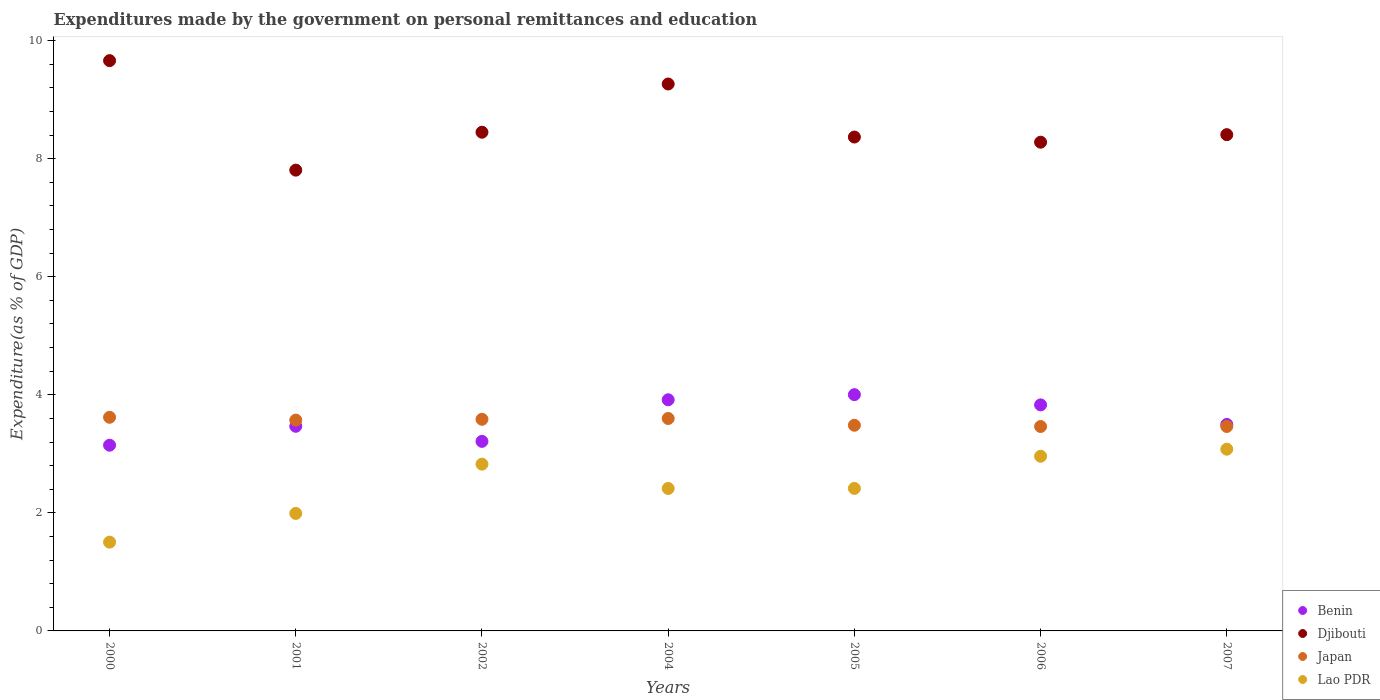Is the number of dotlines equal to the number of legend labels?
Ensure brevity in your answer.  Yes. What is the expenditures made by the government on personal remittances and education in Japan in 2001?
Keep it short and to the point. 3.57. Across all years, what is the maximum expenditures made by the government on personal remittances and education in Japan?
Provide a succinct answer. 3.62. Across all years, what is the minimum expenditures made by the government on personal remittances and education in Lao PDR?
Offer a terse response. 1.5. In which year was the expenditures made by the government on personal remittances and education in Lao PDR minimum?
Offer a terse response. 2000. What is the total expenditures made by the government on personal remittances and education in Djibouti in the graph?
Your answer should be compact. 60.23. What is the difference between the expenditures made by the government on personal remittances and education in Japan in 2001 and that in 2007?
Ensure brevity in your answer.  0.11. What is the difference between the expenditures made by the government on personal remittances and education in Benin in 2002 and the expenditures made by the government on personal remittances and education in Lao PDR in 2007?
Offer a very short reply. 0.13. What is the average expenditures made by the government on personal remittances and education in Benin per year?
Your answer should be compact. 3.58. In the year 2006, what is the difference between the expenditures made by the government on personal remittances and education in Djibouti and expenditures made by the government on personal remittances and education in Japan?
Your answer should be compact. 4.82. In how many years, is the expenditures made by the government on personal remittances and education in Lao PDR greater than 2 %?
Provide a short and direct response. 5. What is the ratio of the expenditures made by the government on personal remittances and education in Benin in 2002 to that in 2004?
Provide a succinct answer. 0.82. Is the difference between the expenditures made by the government on personal remittances and education in Djibouti in 2004 and 2005 greater than the difference between the expenditures made by the government on personal remittances and education in Japan in 2004 and 2005?
Your response must be concise. Yes. What is the difference between the highest and the second highest expenditures made by the government on personal remittances and education in Djibouti?
Your answer should be compact. 0.4. What is the difference between the highest and the lowest expenditures made by the government on personal remittances and education in Djibouti?
Your response must be concise. 1.85. Is the sum of the expenditures made by the government on personal remittances and education in Japan in 2000 and 2004 greater than the maximum expenditures made by the government on personal remittances and education in Benin across all years?
Your response must be concise. Yes. Is it the case that in every year, the sum of the expenditures made by the government on personal remittances and education in Japan and expenditures made by the government on personal remittances and education in Lao PDR  is greater than the sum of expenditures made by the government on personal remittances and education in Djibouti and expenditures made by the government on personal remittances and education in Benin?
Your answer should be very brief. No. Is it the case that in every year, the sum of the expenditures made by the government on personal remittances and education in Lao PDR and expenditures made by the government on personal remittances and education in Japan  is greater than the expenditures made by the government on personal remittances and education in Djibouti?
Your answer should be very brief. No. Does the expenditures made by the government on personal remittances and education in Benin monotonically increase over the years?
Keep it short and to the point. No. How many dotlines are there?
Your answer should be compact. 4. How many years are there in the graph?
Keep it short and to the point. 7. Are the values on the major ticks of Y-axis written in scientific E-notation?
Provide a short and direct response. No. How many legend labels are there?
Keep it short and to the point. 4. What is the title of the graph?
Your response must be concise. Expenditures made by the government on personal remittances and education. What is the label or title of the Y-axis?
Provide a short and direct response. Expenditure(as % of GDP). What is the Expenditure(as % of GDP) in Benin in 2000?
Your answer should be compact. 3.15. What is the Expenditure(as % of GDP) in Djibouti in 2000?
Give a very brief answer. 9.66. What is the Expenditure(as % of GDP) in Japan in 2000?
Give a very brief answer. 3.62. What is the Expenditure(as % of GDP) in Lao PDR in 2000?
Give a very brief answer. 1.5. What is the Expenditure(as % of GDP) of Benin in 2001?
Your response must be concise. 3.47. What is the Expenditure(as % of GDP) of Djibouti in 2001?
Offer a very short reply. 7.81. What is the Expenditure(as % of GDP) of Japan in 2001?
Offer a very short reply. 3.57. What is the Expenditure(as % of GDP) of Lao PDR in 2001?
Offer a terse response. 1.99. What is the Expenditure(as % of GDP) in Benin in 2002?
Provide a succinct answer. 3.21. What is the Expenditure(as % of GDP) in Djibouti in 2002?
Ensure brevity in your answer.  8.45. What is the Expenditure(as % of GDP) in Japan in 2002?
Provide a succinct answer. 3.59. What is the Expenditure(as % of GDP) in Lao PDR in 2002?
Give a very brief answer. 2.83. What is the Expenditure(as % of GDP) of Benin in 2004?
Your answer should be very brief. 3.92. What is the Expenditure(as % of GDP) in Djibouti in 2004?
Give a very brief answer. 9.26. What is the Expenditure(as % of GDP) of Japan in 2004?
Provide a succinct answer. 3.6. What is the Expenditure(as % of GDP) in Lao PDR in 2004?
Make the answer very short. 2.41. What is the Expenditure(as % of GDP) of Benin in 2005?
Make the answer very short. 4. What is the Expenditure(as % of GDP) in Djibouti in 2005?
Make the answer very short. 8.37. What is the Expenditure(as % of GDP) of Japan in 2005?
Your answer should be very brief. 3.48. What is the Expenditure(as % of GDP) of Lao PDR in 2005?
Keep it short and to the point. 2.41. What is the Expenditure(as % of GDP) of Benin in 2006?
Give a very brief answer. 3.83. What is the Expenditure(as % of GDP) of Djibouti in 2006?
Ensure brevity in your answer.  8.28. What is the Expenditure(as % of GDP) in Japan in 2006?
Your response must be concise. 3.46. What is the Expenditure(as % of GDP) of Lao PDR in 2006?
Your answer should be very brief. 2.96. What is the Expenditure(as % of GDP) in Benin in 2007?
Your answer should be very brief. 3.5. What is the Expenditure(as % of GDP) of Djibouti in 2007?
Provide a succinct answer. 8.41. What is the Expenditure(as % of GDP) of Japan in 2007?
Offer a terse response. 3.46. What is the Expenditure(as % of GDP) in Lao PDR in 2007?
Keep it short and to the point. 3.08. Across all years, what is the maximum Expenditure(as % of GDP) in Benin?
Make the answer very short. 4. Across all years, what is the maximum Expenditure(as % of GDP) of Djibouti?
Offer a very short reply. 9.66. Across all years, what is the maximum Expenditure(as % of GDP) of Japan?
Provide a succinct answer. 3.62. Across all years, what is the maximum Expenditure(as % of GDP) of Lao PDR?
Give a very brief answer. 3.08. Across all years, what is the minimum Expenditure(as % of GDP) in Benin?
Ensure brevity in your answer.  3.15. Across all years, what is the minimum Expenditure(as % of GDP) of Djibouti?
Keep it short and to the point. 7.81. Across all years, what is the minimum Expenditure(as % of GDP) of Japan?
Provide a short and direct response. 3.46. Across all years, what is the minimum Expenditure(as % of GDP) of Lao PDR?
Your response must be concise. 1.5. What is the total Expenditure(as % of GDP) in Benin in the graph?
Offer a very short reply. 25.07. What is the total Expenditure(as % of GDP) in Djibouti in the graph?
Ensure brevity in your answer.  60.23. What is the total Expenditure(as % of GDP) of Japan in the graph?
Your answer should be compact. 24.78. What is the total Expenditure(as % of GDP) in Lao PDR in the graph?
Give a very brief answer. 17.18. What is the difference between the Expenditure(as % of GDP) in Benin in 2000 and that in 2001?
Your response must be concise. -0.32. What is the difference between the Expenditure(as % of GDP) in Djibouti in 2000 and that in 2001?
Keep it short and to the point. 1.85. What is the difference between the Expenditure(as % of GDP) of Japan in 2000 and that in 2001?
Offer a terse response. 0.05. What is the difference between the Expenditure(as % of GDP) of Lao PDR in 2000 and that in 2001?
Give a very brief answer. -0.49. What is the difference between the Expenditure(as % of GDP) of Benin in 2000 and that in 2002?
Ensure brevity in your answer.  -0.07. What is the difference between the Expenditure(as % of GDP) of Djibouti in 2000 and that in 2002?
Your answer should be compact. 1.21. What is the difference between the Expenditure(as % of GDP) in Japan in 2000 and that in 2002?
Ensure brevity in your answer.  0.03. What is the difference between the Expenditure(as % of GDP) in Lao PDR in 2000 and that in 2002?
Provide a short and direct response. -1.32. What is the difference between the Expenditure(as % of GDP) of Benin in 2000 and that in 2004?
Your answer should be compact. -0.77. What is the difference between the Expenditure(as % of GDP) in Djibouti in 2000 and that in 2004?
Provide a short and direct response. 0.4. What is the difference between the Expenditure(as % of GDP) in Japan in 2000 and that in 2004?
Your answer should be very brief. 0.02. What is the difference between the Expenditure(as % of GDP) in Lao PDR in 2000 and that in 2004?
Your answer should be compact. -0.91. What is the difference between the Expenditure(as % of GDP) of Benin in 2000 and that in 2005?
Make the answer very short. -0.86. What is the difference between the Expenditure(as % of GDP) in Djibouti in 2000 and that in 2005?
Keep it short and to the point. 1.29. What is the difference between the Expenditure(as % of GDP) in Japan in 2000 and that in 2005?
Ensure brevity in your answer.  0.14. What is the difference between the Expenditure(as % of GDP) in Lao PDR in 2000 and that in 2005?
Make the answer very short. -0.91. What is the difference between the Expenditure(as % of GDP) of Benin in 2000 and that in 2006?
Give a very brief answer. -0.68. What is the difference between the Expenditure(as % of GDP) in Djibouti in 2000 and that in 2006?
Your response must be concise. 1.38. What is the difference between the Expenditure(as % of GDP) of Japan in 2000 and that in 2006?
Provide a short and direct response. 0.16. What is the difference between the Expenditure(as % of GDP) in Lao PDR in 2000 and that in 2006?
Keep it short and to the point. -1.46. What is the difference between the Expenditure(as % of GDP) of Benin in 2000 and that in 2007?
Your response must be concise. -0.35. What is the difference between the Expenditure(as % of GDP) of Djibouti in 2000 and that in 2007?
Your response must be concise. 1.25. What is the difference between the Expenditure(as % of GDP) in Japan in 2000 and that in 2007?
Ensure brevity in your answer.  0.16. What is the difference between the Expenditure(as % of GDP) in Lao PDR in 2000 and that in 2007?
Your answer should be compact. -1.57. What is the difference between the Expenditure(as % of GDP) in Benin in 2001 and that in 2002?
Ensure brevity in your answer.  0.26. What is the difference between the Expenditure(as % of GDP) in Djibouti in 2001 and that in 2002?
Your response must be concise. -0.64. What is the difference between the Expenditure(as % of GDP) of Japan in 2001 and that in 2002?
Ensure brevity in your answer.  -0.01. What is the difference between the Expenditure(as % of GDP) of Lao PDR in 2001 and that in 2002?
Provide a succinct answer. -0.83. What is the difference between the Expenditure(as % of GDP) of Benin in 2001 and that in 2004?
Your answer should be very brief. -0.45. What is the difference between the Expenditure(as % of GDP) of Djibouti in 2001 and that in 2004?
Ensure brevity in your answer.  -1.46. What is the difference between the Expenditure(as % of GDP) of Japan in 2001 and that in 2004?
Your response must be concise. -0.03. What is the difference between the Expenditure(as % of GDP) in Lao PDR in 2001 and that in 2004?
Provide a short and direct response. -0.42. What is the difference between the Expenditure(as % of GDP) in Benin in 2001 and that in 2005?
Offer a very short reply. -0.54. What is the difference between the Expenditure(as % of GDP) in Djibouti in 2001 and that in 2005?
Your answer should be compact. -0.56. What is the difference between the Expenditure(as % of GDP) of Japan in 2001 and that in 2005?
Your response must be concise. 0.09. What is the difference between the Expenditure(as % of GDP) in Lao PDR in 2001 and that in 2005?
Give a very brief answer. -0.42. What is the difference between the Expenditure(as % of GDP) of Benin in 2001 and that in 2006?
Provide a succinct answer. -0.36. What is the difference between the Expenditure(as % of GDP) in Djibouti in 2001 and that in 2006?
Your response must be concise. -0.47. What is the difference between the Expenditure(as % of GDP) of Japan in 2001 and that in 2006?
Your response must be concise. 0.11. What is the difference between the Expenditure(as % of GDP) in Lao PDR in 2001 and that in 2006?
Offer a very short reply. -0.97. What is the difference between the Expenditure(as % of GDP) in Benin in 2001 and that in 2007?
Your answer should be very brief. -0.03. What is the difference between the Expenditure(as % of GDP) of Djibouti in 2001 and that in 2007?
Offer a terse response. -0.6. What is the difference between the Expenditure(as % of GDP) in Japan in 2001 and that in 2007?
Ensure brevity in your answer.  0.11. What is the difference between the Expenditure(as % of GDP) of Lao PDR in 2001 and that in 2007?
Offer a terse response. -1.09. What is the difference between the Expenditure(as % of GDP) of Benin in 2002 and that in 2004?
Keep it short and to the point. -0.7. What is the difference between the Expenditure(as % of GDP) in Djibouti in 2002 and that in 2004?
Ensure brevity in your answer.  -0.82. What is the difference between the Expenditure(as % of GDP) of Japan in 2002 and that in 2004?
Your answer should be compact. -0.01. What is the difference between the Expenditure(as % of GDP) of Lao PDR in 2002 and that in 2004?
Keep it short and to the point. 0.41. What is the difference between the Expenditure(as % of GDP) of Benin in 2002 and that in 2005?
Offer a terse response. -0.79. What is the difference between the Expenditure(as % of GDP) in Djibouti in 2002 and that in 2005?
Ensure brevity in your answer.  0.08. What is the difference between the Expenditure(as % of GDP) of Japan in 2002 and that in 2005?
Make the answer very short. 0.1. What is the difference between the Expenditure(as % of GDP) in Lao PDR in 2002 and that in 2005?
Provide a short and direct response. 0.41. What is the difference between the Expenditure(as % of GDP) in Benin in 2002 and that in 2006?
Your response must be concise. -0.62. What is the difference between the Expenditure(as % of GDP) of Djibouti in 2002 and that in 2006?
Make the answer very short. 0.17. What is the difference between the Expenditure(as % of GDP) in Japan in 2002 and that in 2006?
Offer a terse response. 0.12. What is the difference between the Expenditure(as % of GDP) in Lao PDR in 2002 and that in 2006?
Provide a short and direct response. -0.13. What is the difference between the Expenditure(as % of GDP) of Benin in 2002 and that in 2007?
Offer a terse response. -0.29. What is the difference between the Expenditure(as % of GDP) of Djibouti in 2002 and that in 2007?
Offer a terse response. 0.04. What is the difference between the Expenditure(as % of GDP) in Japan in 2002 and that in 2007?
Make the answer very short. 0.12. What is the difference between the Expenditure(as % of GDP) of Lao PDR in 2002 and that in 2007?
Offer a very short reply. -0.25. What is the difference between the Expenditure(as % of GDP) of Benin in 2004 and that in 2005?
Provide a succinct answer. -0.09. What is the difference between the Expenditure(as % of GDP) in Djibouti in 2004 and that in 2005?
Provide a short and direct response. 0.9. What is the difference between the Expenditure(as % of GDP) of Japan in 2004 and that in 2005?
Ensure brevity in your answer.  0.11. What is the difference between the Expenditure(as % of GDP) in Lao PDR in 2004 and that in 2005?
Provide a succinct answer. -0. What is the difference between the Expenditure(as % of GDP) of Benin in 2004 and that in 2006?
Keep it short and to the point. 0.09. What is the difference between the Expenditure(as % of GDP) in Djibouti in 2004 and that in 2006?
Offer a very short reply. 0.99. What is the difference between the Expenditure(as % of GDP) of Japan in 2004 and that in 2006?
Give a very brief answer. 0.14. What is the difference between the Expenditure(as % of GDP) in Lao PDR in 2004 and that in 2006?
Offer a terse response. -0.55. What is the difference between the Expenditure(as % of GDP) in Benin in 2004 and that in 2007?
Ensure brevity in your answer.  0.42. What is the difference between the Expenditure(as % of GDP) in Djibouti in 2004 and that in 2007?
Provide a short and direct response. 0.86. What is the difference between the Expenditure(as % of GDP) in Japan in 2004 and that in 2007?
Your answer should be compact. 0.13. What is the difference between the Expenditure(as % of GDP) of Lao PDR in 2004 and that in 2007?
Your answer should be compact. -0.67. What is the difference between the Expenditure(as % of GDP) of Benin in 2005 and that in 2006?
Make the answer very short. 0.17. What is the difference between the Expenditure(as % of GDP) in Djibouti in 2005 and that in 2006?
Your response must be concise. 0.09. What is the difference between the Expenditure(as % of GDP) of Japan in 2005 and that in 2006?
Make the answer very short. 0.02. What is the difference between the Expenditure(as % of GDP) of Lao PDR in 2005 and that in 2006?
Keep it short and to the point. -0.54. What is the difference between the Expenditure(as % of GDP) in Benin in 2005 and that in 2007?
Provide a succinct answer. 0.5. What is the difference between the Expenditure(as % of GDP) in Djibouti in 2005 and that in 2007?
Give a very brief answer. -0.04. What is the difference between the Expenditure(as % of GDP) in Japan in 2005 and that in 2007?
Keep it short and to the point. 0.02. What is the difference between the Expenditure(as % of GDP) of Lao PDR in 2005 and that in 2007?
Keep it short and to the point. -0.66. What is the difference between the Expenditure(as % of GDP) of Benin in 2006 and that in 2007?
Your response must be concise. 0.33. What is the difference between the Expenditure(as % of GDP) in Djibouti in 2006 and that in 2007?
Keep it short and to the point. -0.13. What is the difference between the Expenditure(as % of GDP) of Japan in 2006 and that in 2007?
Give a very brief answer. -0. What is the difference between the Expenditure(as % of GDP) in Lao PDR in 2006 and that in 2007?
Make the answer very short. -0.12. What is the difference between the Expenditure(as % of GDP) of Benin in 2000 and the Expenditure(as % of GDP) of Djibouti in 2001?
Ensure brevity in your answer.  -4.66. What is the difference between the Expenditure(as % of GDP) in Benin in 2000 and the Expenditure(as % of GDP) in Japan in 2001?
Offer a very short reply. -0.43. What is the difference between the Expenditure(as % of GDP) of Benin in 2000 and the Expenditure(as % of GDP) of Lao PDR in 2001?
Your response must be concise. 1.16. What is the difference between the Expenditure(as % of GDP) of Djibouti in 2000 and the Expenditure(as % of GDP) of Japan in 2001?
Make the answer very short. 6.09. What is the difference between the Expenditure(as % of GDP) in Djibouti in 2000 and the Expenditure(as % of GDP) in Lao PDR in 2001?
Offer a terse response. 7.67. What is the difference between the Expenditure(as % of GDP) in Japan in 2000 and the Expenditure(as % of GDP) in Lao PDR in 2001?
Your answer should be very brief. 1.63. What is the difference between the Expenditure(as % of GDP) of Benin in 2000 and the Expenditure(as % of GDP) of Djibouti in 2002?
Give a very brief answer. -5.3. What is the difference between the Expenditure(as % of GDP) of Benin in 2000 and the Expenditure(as % of GDP) of Japan in 2002?
Make the answer very short. -0.44. What is the difference between the Expenditure(as % of GDP) in Benin in 2000 and the Expenditure(as % of GDP) in Lao PDR in 2002?
Your response must be concise. 0.32. What is the difference between the Expenditure(as % of GDP) of Djibouti in 2000 and the Expenditure(as % of GDP) of Japan in 2002?
Offer a terse response. 6.07. What is the difference between the Expenditure(as % of GDP) of Djibouti in 2000 and the Expenditure(as % of GDP) of Lao PDR in 2002?
Make the answer very short. 6.83. What is the difference between the Expenditure(as % of GDP) of Japan in 2000 and the Expenditure(as % of GDP) of Lao PDR in 2002?
Keep it short and to the point. 0.79. What is the difference between the Expenditure(as % of GDP) in Benin in 2000 and the Expenditure(as % of GDP) in Djibouti in 2004?
Your response must be concise. -6.12. What is the difference between the Expenditure(as % of GDP) of Benin in 2000 and the Expenditure(as % of GDP) of Japan in 2004?
Your response must be concise. -0.45. What is the difference between the Expenditure(as % of GDP) in Benin in 2000 and the Expenditure(as % of GDP) in Lao PDR in 2004?
Offer a terse response. 0.73. What is the difference between the Expenditure(as % of GDP) of Djibouti in 2000 and the Expenditure(as % of GDP) of Japan in 2004?
Make the answer very short. 6.06. What is the difference between the Expenditure(as % of GDP) of Djibouti in 2000 and the Expenditure(as % of GDP) of Lao PDR in 2004?
Provide a short and direct response. 7.25. What is the difference between the Expenditure(as % of GDP) of Japan in 2000 and the Expenditure(as % of GDP) of Lao PDR in 2004?
Your answer should be very brief. 1.21. What is the difference between the Expenditure(as % of GDP) in Benin in 2000 and the Expenditure(as % of GDP) in Djibouti in 2005?
Your answer should be compact. -5.22. What is the difference between the Expenditure(as % of GDP) of Benin in 2000 and the Expenditure(as % of GDP) of Japan in 2005?
Provide a succinct answer. -0.34. What is the difference between the Expenditure(as % of GDP) in Benin in 2000 and the Expenditure(as % of GDP) in Lao PDR in 2005?
Give a very brief answer. 0.73. What is the difference between the Expenditure(as % of GDP) of Djibouti in 2000 and the Expenditure(as % of GDP) of Japan in 2005?
Your answer should be very brief. 6.18. What is the difference between the Expenditure(as % of GDP) in Djibouti in 2000 and the Expenditure(as % of GDP) in Lao PDR in 2005?
Ensure brevity in your answer.  7.25. What is the difference between the Expenditure(as % of GDP) in Japan in 2000 and the Expenditure(as % of GDP) in Lao PDR in 2005?
Your response must be concise. 1.2. What is the difference between the Expenditure(as % of GDP) of Benin in 2000 and the Expenditure(as % of GDP) of Djibouti in 2006?
Your answer should be very brief. -5.13. What is the difference between the Expenditure(as % of GDP) in Benin in 2000 and the Expenditure(as % of GDP) in Japan in 2006?
Ensure brevity in your answer.  -0.32. What is the difference between the Expenditure(as % of GDP) in Benin in 2000 and the Expenditure(as % of GDP) in Lao PDR in 2006?
Provide a short and direct response. 0.19. What is the difference between the Expenditure(as % of GDP) of Djibouti in 2000 and the Expenditure(as % of GDP) of Japan in 2006?
Provide a succinct answer. 6.2. What is the difference between the Expenditure(as % of GDP) of Djibouti in 2000 and the Expenditure(as % of GDP) of Lao PDR in 2006?
Offer a very short reply. 6.7. What is the difference between the Expenditure(as % of GDP) in Japan in 2000 and the Expenditure(as % of GDP) in Lao PDR in 2006?
Your response must be concise. 0.66. What is the difference between the Expenditure(as % of GDP) of Benin in 2000 and the Expenditure(as % of GDP) of Djibouti in 2007?
Offer a terse response. -5.26. What is the difference between the Expenditure(as % of GDP) of Benin in 2000 and the Expenditure(as % of GDP) of Japan in 2007?
Your answer should be very brief. -0.32. What is the difference between the Expenditure(as % of GDP) of Benin in 2000 and the Expenditure(as % of GDP) of Lao PDR in 2007?
Your answer should be compact. 0.07. What is the difference between the Expenditure(as % of GDP) of Djibouti in 2000 and the Expenditure(as % of GDP) of Japan in 2007?
Give a very brief answer. 6.2. What is the difference between the Expenditure(as % of GDP) in Djibouti in 2000 and the Expenditure(as % of GDP) in Lao PDR in 2007?
Keep it short and to the point. 6.58. What is the difference between the Expenditure(as % of GDP) in Japan in 2000 and the Expenditure(as % of GDP) in Lao PDR in 2007?
Give a very brief answer. 0.54. What is the difference between the Expenditure(as % of GDP) of Benin in 2001 and the Expenditure(as % of GDP) of Djibouti in 2002?
Give a very brief answer. -4.98. What is the difference between the Expenditure(as % of GDP) of Benin in 2001 and the Expenditure(as % of GDP) of Japan in 2002?
Make the answer very short. -0.12. What is the difference between the Expenditure(as % of GDP) in Benin in 2001 and the Expenditure(as % of GDP) in Lao PDR in 2002?
Your response must be concise. 0.64. What is the difference between the Expenditure(as % of GDP) of Djibouti in 2001 and the Expenditure(as % of GDP) of Japan in 2002?
Keep it short and to the point. 4.22. What is the difference between the Expenditure(as % of GDP) in Djibouti in 2001 and the Expenditure(as % of GDP) in Lao PDR in 2002?
Give a very brief answer. 4.98. What is the difference between the Expenditure(as % of GDP) of Japan in 2001 and the Expenditure(as % of GDP) of Lao PDR in 2002?
Provide a short and direct response. 0.75. What is the difference between the Expenditure(as % of GDP) of Benin in 2001 and the Expenditure(as % of GDP) of Djibouti in 2004?
Provide a short and direct response. -5.8. What is the difference between the Expenditure(as % of GDP) in Benin in 2001 and the Expenditure(as % of GDP) in Japan in 2004?
Your answer should be very brief. -0.13. What is the difference between the Expenditure(as % of GDP) in Benin in 2001 and the Expenditure(as % of GDP) in Lao PDR in 2004?
Your answer should be compact. 1.05. What is the difference between the Expenditure(as % of GDP) of Djibouti in 2001 and the Expenditure(as % of GDP) of Japan in 2004?
Give a very brief answer. 4.21. What is the difference between the Expenditure(as % of GDP) in Djibouti in 2001 and the Expenditure(as % of GDP) in Lao PDR in 2004?
Provide a short and direct response. 5.39. What is the difference between the Expenditure(as % of GDP) of Japan in 2001 and the Expenditure(as % of GDP) of Lao PDR in 2004?
Your answer should be very brief. 1.16. What is the difference between the Expenditure(as % of GDP) in Benin in 2001 and the Expenditure(as % of GDP) in Djibouti in 2005?
Offer a terse response. -4.9. What is the difference between the Expenditure(as % of GDP) of Benin in 2001 and the Expenditure(as % of GDP) of Japan in 2005?
Keep it short and to the point. -0.02. What is the difference between the Expenditure(as % of GDP) of Benin in 2001 and the Expenditure(as % of GDP) of Lao PDR in 2005?
Give a very brief answer. 1.05. What is the difference between the Expenditure(as % of GDP) in Djibouti in 2001 and the Expenditure(as % of GDP) in Japan in 2005?
Keep it short and to the point. 4.32. What is the difference between the Expenditure(as % of GDP) in Djibouti in 2001 and the Expenditure(as % of GDP) in Lao PDR in 2005?
Your answer should be very brief. 5.39. What is the difference between the Expenditure(as % of GDP) of Japan in 2001 and the Expenditure(as % of GDP) of Lao PDR in 2005?
Your answer should be very brief. 1.16. What is the difference between the Expenditure(as % of GDP) in Benin in 2001 and the Expenditure(as % of GDP) in Djibouti in 2006?
Ensure brevity in your answer.  -4.81. What is the difference between the Expenditure(as % of GDP) of Benin in 2001 and the Expenditure(as % of GDP) of Japan in 2006?
Keep it short and to the point. 0. What is the difference between the Expenditure(as % of GDP) in Benin in 2001 and the Expenditure(as % of GDP) in Lao PDR in 2006?
Provide a short and direct response. 0.51. What is the difference between the Expenditure(as % of GDP) of Djibouti in 2001 and the Expenditure(as % of GDP) of Japan in 2006?
Ensure brevity in your answer.  4.34. What is the difference between the Expenditure(as % of GDP) of Djibouti in 2001 and the Expenditure(as % of GDP) of Lao PDR in 2006?
Offer a terse response. 4.85. What is the difference between the Expenditure(as % of GDP) of Japan in 2001 and the Expenditure(as % of GDP) of Lao PDR in 2006?
Your answer should be compact. 0.61. What is the difference between the Expenditure(as % of GDP) in Benin in 2001 and the Expenditure(as % of GDP) in Djibouti in 2007?
Your answer should be very brief. -4.94. What is the difference between the Expenditure(as % of GDP) in Benin in 2001 and the Expenditure(as % of GDP) in Japan in 2007?
Your answer should be very brief. 0. What is the difference between the Expenditure(as % of GDP) in Benin in 2001 and the Expenditure(as % of GDP) in Lao PDR in 2007?
Your response must be concise. 0.39. What is the difference between the Expenditure(as % of GDP) in Djibouti in 2001 and the Expenditure(as % of GDP) in Japan in 2007?
Provide a short and direct response. 4.34. What is the difference between the Expenditure(as % of GDP) of Djibouti in 2001 and the Expenditure(as % of GDP) of Lao PDR in 2007?
Make the answer very short. 4.73. What is the difference between the Expenditure(as % of GDP) in Japan in 2001 and the Expenditure(as % of GDP) in Lao PDR in 2007?
Offer a terse response. 0.49. What is the difference between the Expenditure(as % of GDP) in Benin in 2002 and the Expenditure(as % of GDP) in Djibouti in 2004?
Give a very brief answer. -6.05. What is the difference between the Expenditure(as % of GDP) of Benin in 2002 and the Expenditure(as % of GDP) of Japan in 2004?
Provide a short and direct response. -0.39. What is the difference between the Expenditure(as % of GDP) in Benin in 2002 and the Expenditure(as % of GDP) in Lao PDR in 2004?
Give a very brief answer. 0.8. What is the difference between the Expenditure(as % of GDP) of Djibouti in 2002 and the Expenditure(as % of GDP) of Japan in 2004?
Your response must be concise. 4.85. What is the difference between the Expenditure(as % of GDP) in Djibouti in 2002 and the Expenditure(as % of GDP) in Lao PDR in 2004?
Your answer should be compact. 6.03. What is the difference between the Expenditure(as % of GDP) in Japan in 2002 and the Expenditure(as % of GDP) in Lao PDR in 2004?
Give a very brief answer. 1.17. What is the difference between the Expenditure(as % of GDP) in Benin in 2002 and the Expenditure(as % of GDP) in Djibouti in 2005?
Your answer should be very brief. -5.16. What is the difference between the Expenditure(as % of GDP) in Benin in 2002 and the Expenditure(as % of GDP) in Japan in 2005?
Ensure brevity in your answer.  -0.27. What is the difference between the Expenditure(as % of GDP) in Benin in 2002 and the Expenditure(as % of GDP) in Lao PDR in 2005?
Make the answer very short. 0.8. What is the difference between the Expenditure(as % of GDP) in Djibouti in 2002 and the Expenditure(as % of GDP) in Japan in 2005?
Your answer should be compact. 4.96. What is the difference between the Expenditure(as % of GDP) of Djibouti in 2002 and the Expenditure(as % of GDP) of Lao PDR in 2005?
Make the answer very short. 6.03. What is the difference between the Expenditure(as % of GDP) of Japan in 2002 and the Expenditure(as % of GDP) of Lao PDR in 2005?
Offer a very short reply. 1.17. What is the difference between the Expenditure(as % of GDP) of Benin in 2002 and the Expenditure(as % of GDP) of Djibouti in 2006?
Give a very brief answer. -5.07. What is the difference between the Expenditure(as % of GDP) in Benin in 2002 and the Expenditure(as % of GDP) in Japan in 2006?
Offer a very short reply. -0.25. What is the difference between the Expenditure(as % of GDP) in Benin in 2002 and the Expenditure(as % of GDP) in Lao PDR in 2006?
Your response must be concise. 0.25. What is the difference between the Expenditure(as % of GDP) in Djibouti in 2002 and the Expenditure(as % of GDP) in Japan in 2006?
Offer a very short reply. 4.98. What is the difference between the Expenditure(as % of GDP) of Djibouti in 2002 and the Expenditure(as % of GDP) of Lao PDR in 2006?
Offer a very short reply. 5.49. What is the difference between the Expenditure(as % of GDP) of Japan in 2002 and the Expenditure(as % of GDP) of Lao PDR in 2006?
Provide a succinct answer. 0.63. What is the difference between the Expenditure(as % of GDP) in Benin in 2002 and the Expenditure(as % of GDP) in Djibouti in 2007?
Provide a succinct answer. -5.2. What is the difference between the Expenditure(as % of GDP) of Benin in 2002 and the Expenditure(as % of GDP) of Japan in 2007?
Provide a short and direct response. -0.25. What is the difference between the Expenditure(as % of GDP) of Benin in 2002 and the Expenditure(as % of GDP) of Lao PDR in 2007?
Your answer should be compact. 0.13. What is the difference between the Expenditure(as % of GDP) of Djibouti in 2002 and the Expenditure(as % of GDP) of Japan in 2007?
Offer a very short reply. 4.98. What is the difference between the Expenditure(as % of GDP) of Djibouti in 2002 and the Expenditure(as % of GDP) of Lao PDR in 2007?
Your response must be concise. 5.37. What is the difference between the Expenditure(as % of GDP) in Japan in 2002 and the Expenditure(as % of GDP) in Lao PDR in 2007?
Your answer should be compact. 0.51. What is the difference between the Expenditure(as % of GDP) of Benin in 2004 and the Expenditure(as % of GDP) of Djibouti in 2005?
Your response must be concise. -4.45. What is the difference between the Expenditure(as % of GDP) in Benin in 2004 and the Expenditure(as % of GDP) in Japan in 2005?
Give a very brief answer. 0.43. What is the difference between the Expenditure(as % of GDP) in Benin in 2004 and the Expenditure(as % of GDP) in Lao PDR in 2005?
Provide a succinct answer. 1.5. What is the difference between the Expenditure(as % of GDP) in Djibouti in 2004 and the Expenditure(as % of GDP) in Japan in 2005?
Offer a very short reply. 5.78. What is the difference between the Expenditure(as % of GDP) of Djibouti in 2004 and the Expenditure(as % of GDP) of Lao PDR in 2005?
Your answer should be compact. 6.85. What is the difference between the Expenditure(as % of GDP) in Japan in 2004 and the Expenditure(as % of GDP) in Lao PDR in 2005?
Your response must be concise. 1.18. What is the difference between the Expenditure(as % of GDP) of Benin in 2004 and the Expenditure(as % of GDP) of Djibouti in 2006?
Your answer should be very brief. -4.36. What is the difference between the Expenditure(as % of GDP) of Benin in 2004 and the Expenditure(as % of GDP) of Japan in 2006?
Your answer should be very brief. 0.45. What is the difference between the Expenditure(as % of GDP) in Benin in 2004 and the Expenditure(as % of GDP) in Lao PDR in 2006?
Your answer should be compact. 0.96. What is the difference between the Expenditure(as % of GDP) in Djibouti in 2004 and the Expenditure(as % of GDP) in Japan in 2006?
Your answer should be compact. 5.8. What is the difference between the Expenditure(as % of GDP) of Djibouti in 2004 and the Expenditure(as % of GDP) of Lao PDR in 2006?
Make the answer very short. 6.31. What is the difference between the Expenditure(as % of GDP) in Japan in 2004 and the Expenditure(as % of GDP) in Lao PDR in 2006?
Offer a very short reply. 0.64. What is the difference between the Expenditure(as % of GDP) of Benin in 2004 and the Expenditure(as % of GDP) of Djibouti in 2007?
Give a very brief answer. -4.49. What is the difference between the Expenditure(as % of GDP) in Benin in 2004 and the Expenditure(as % of GDP) in Japan in 2007?
Your answer should be compact. 0.45. What is the difference between the Expenditure(as % of GDP) of Benin in 2004 and the Expenditure(as % of GDP) of Lao PDR in 2007?
Give a very brief answer. 0.84. What is the difference between the Expenditure(as % of GDP) in Djibouti in 2004 and the Expenditure(as % of GDP) in Japan in 2007?
Provide a short and direct response. 5.8. What is the difference between the Expenditure(as % of GDP) of Djibouti in 2004 and the Expenditure(as % of GDP) of Lao PDR in 2007?
Offer a very short reply. 6.19. What is the difference between the Expenditure(as % of GDP) of Japan in 2004 and the Expenditure(as % of GDP) of Lao PDR in 2007?
Offer a very short reply. 0.52. What is the difference between the Expenditure(as % of GDP) of Benin in 2005 and the Expenditure(as % of GDP) of Djibouti in 2006?
Give a very brief answer. -4.28. What is the difference between the Expenditure(as % of GDP) of Benin in 2005 and the Expenditure(as % of GDP) of Japan in 2006?
Your answer should be compact. 0.54. What is the difference between the Expenditure(as % of GDP) of Benin in 2005 and the Expenditure(as % of GDP) of Lao PDR in 2006?
Offer a very short reply. 1.04. What is the difference between the Expenditure(as % of GDP) in Djibouti in 2005 and the Expenditure(as % of GDP) in Japan in 2006?
Make the answer very short. 4.9. What is the difference between the Expenditure(as % of GDP) of Djibouti in 2005 and the Expenditure(as % of GDP) of Lao PDR in 2006?
Make the answer very short. 5.41. What is the difference between the Expenditure(as % of GDP) in Japan in 2005 and the Expenditure(as % of GDP) in Lao PDR in 2006?
Offer a terse response. 0.53. What is the difference between the Expenditure(as % of GDP) in Benin in 2005 and the Expenditure(as % of GDP) in Djibouti in 2007?
Provide a succinct answer. -4.4. What is the difference between the Expenditure(as % of GDP) in Benin in 2005 and the Expenditure(as % of GDP) in Japan in 2007?
Your response must be concise. 0.54. What is the difference between the Expenditure(as % of GDP) of Benin in 2005 and the Expenditure(as % of GDP) of Lao PDR in 2007?
Your answer should be compact. 0.92. What is the difference between the Expenditure(as % of GDP) of Djibouti in 2005 and the Expenditure(as % of GDP) of Japan in 2007?
Offer a very short reply. 4.9. What is the difference between the Expenditure(as % of GDP) of Djibouti in 2005 and the Expenditure(as % of GDP) of Lao PDR in 2007?
Keep it short and to the point. 5.29. What is the difference between the Expenditure(as % of GDP) of Japan in 2005 and the Expenditure(as % of GDP) of Lao PDR in 2007?
Make the answer very short. 0.41. What is the difference between the Expenditure(as % of GDP) of Benin in 2006 and the Expenditure(as % of GDP) of Djibouti in 2007?
Ensure brevity in your answer.  -4.58. What is the difference between the Expenditure(as % of GDP) in Benin in 2006 and the Expenditure(as % of GDP) in Japan in 2007?
Provide a succinct answer. 0.37. What is the difference between the Expenditure(as % of GDP) in Benin in 2006 and the Expenditure(as % of GDP) in Lao PDR in 2007?
Offer a very short reply. 0.75. What is the difference between the Expenditure(as % of GDP) in Djibouti in 2006 and the Expenditure(as % of GDP) in Japan in 2007?
Your answer should be compact. 4.82. What is the difference between the Expenditure(as % of GDP) in Djibouti in 2006 and the Expenditure(as % of GDP) in Lao PDR in 2007?
Provide a succinct answer. 5.2. What is the difference between the Expenditure(as % of GDP) in Japan in 2006 and the Expenditure(as % of GDP) in Lao PDR in 2007?
Keep it short and to the point. 0.38. What is the average Expenditure(as % of GDP) in Benin per year?
Provide a succinct answer. 3.58. What is the average Expenditure(as % of GDP) in Djibouti per year?
Your answer should be compact. 8.6. What is the average Expenditure(as % of GDP) in Japan per year?
Your answer should be compact. 3.54. What is the average Expenditure(as % of GDP) in Lao PDR per year?
Provide a short and direct response. 2.45. In the year 2000, what is the difference between the Expenditure(as % of GDP) of Benin and Expenditure(as % of GDP) of Djibouti?
Provide a short and direct response. -6.51. In the year 2000, what is the difference between the Expenditure(as % of GDP) of Benin and Expenditure(as % of GDP) of Japan?
Offer a terse response. -0.47. In the year 2000, what is the difference between the Expenditure(as % of GDP) of Benin and Expenditure(as % of GDP) of Lao PDR?
Your response must be concise. 1.64. In the year 2000, what is the difference between the Expenditure(as % of GDP) of Djibouti and Expenditure(as % of GDP) of Japan?
Offer a very short reply. 6.04. In the year 2000, what is the difference between the Expenditure(as % of GDP) in Djibouti and Expenditure(as % of GDP) in Lao PDR?
Make the answer very short. 8.16. In the year 2000, what is the difference between the Expenditure(as % of GDP) of Japan and Expenditure(as % of GDP) of Lao PDR?
Provide a succinct answer. 2.12. In the year 2001, what is the difference between the Expenditure(as % of GDP) in Benin and Expenditure(as % of GDP) in Djibouti?
Provide a short and direct response. -4.34. In the year 2001, what is the difference between the Expenditure(as % of GDP) of Benin and Expenditure(as % of GDP) of Japan?
Your answer should be very brief. -0.1. In the year 2001, what is the difference between the Expenditure(as % of GDP) in Benin and Expenditure(as % of GDP) in Lao PDR?
Keep it short and to the point. 1.48. In the year 2001, what is the difference between the Expenditure(as % of GDP) of Djibouti and Expenditure(as % of GDP) of Japan?
Make the answer very short. 4.23. In the year 2001, what is the difference between the Expenditure(as % of GDP) in Djibouti and Expenditure(as % of GDP) in Lao PDR?
Your answer should be compact. 5.82. In the year 2001, what is the difference between the Expenditure(as % of GDP) in Japan and Expenditure(as % of GDP) in Lao PDR?
Make the answer very short. 1.58. In the year 2002, what is the difference between the Expenditure(as % of GDP) of Benin and Expenditure(as % of GDP) of Djibouti?
Offer a terse response. -5.24. In the year 2002, what is the difference between the Expenditure(as % of GDP) of Benin and Expenditure(as % of GDP) of Japan?
Keep it short and to the point. -0.37. In the year 2002, what is the difference between the Expenditure(as % of GDP) in Benin and Expenditure(as % of GDP) in Lao PDR?
Make the answer very short. 0.39. In the year 2002, what is the difference between the Expenditure(as % of GDP) in Djibouti and Expenditure(as % of GDP) in Japan?
Ensure brevity in your answer.  4.86. In the year 2002, what is the difference between the Expenditure(as % of GDP) in Djibouti and Expenditure(as % of GDP) in Lao PDR?
Provide a succinct answer. 5.62. In the year 2002, what is the difference between the Expenditure(as % of GDP) of Japan and Expenditure(as % of GDP) of Lao PDR?
Make the answer very short. 0.76. In the year 2004, what is the difference between the Expenditure(as % of GDP) in Benin and Expenditure(as % of GDP) in Djibouti?
Your answer should be very brief. -5.35. In the year 2004, what is the difference between the Expenditure(as % of GDP) of Benin and Expenditure(as % of GDP) of Japan?
Ensure brevity in your answer.  0.32. In the year 2004, what is the difference between the Expenditure(as % of GDP) of Benin and Expenditure(as % of GDP) of Lao PDR?
Offer a terse response. 1.5. In the year 2004, what is the difference between the Expenditure(as % of GDP) in Djibouti and Expenditure(as % of GDP) in Japan?
Your answer should be compact. 5.67. In the year 2004, what is the difference between the Expenditure(as % of GDP) of Djibouti and Expenditure(as % of GDP) of Lao PDR?
Your answer should be very brief. 6.85. In the year 2004, what is the difference between the Expenditure(as % of GDP) in Japan and Expenditure(as % of GDP) in Lao PDR?
Offer a very short reply. 1.19. In the year 2005, what is the difference between the Expenditure(as % of GDP) in Benin and Expenditure(as % of GDP) in Djibouti?
Provide a succinct answer. -4.36. In the year 2005, what is the difference between the Expenditure(as % of GDP) in Benin and Expenditure(as % of GDP) in Japan?
Offer a very short reply. 0.52. In the year 2005, what is the difference between the Expenditure(as % of GDP) in Benin and Expenditure(as % of GDP) in Lao PDR?
Make the answer very short. 1.59. In the year 2005, what is the difference between the Expenditure(as % of GDP) of Djibouti and Expenditure(as % of GDP) of Japan?
Your response must be concise. 4.88. In the year 2005, what is the difference between the Expenditure(as % of GDP) in Djibouti and Expenditure(as % of GDP) in Lao PDR?
Offer a very short reply. 5.95. In the year 2005, what is the difference between the Expenditure(as % of GDP) in Japan and Expenditure(as % of GDP) in Lao PDR?
Your answer should be compact. 1.07. In the year 2006, what is the difference between the Expenditure(as % of GDP) in Benin and Expenditure(as % of GDP) in Djibouti?
Your response must be concise. -4.45. In the year 2006, what is the difference between the Expenditure(as % of GDP) in Benin and Expenditure(as % of GDP) in Japan?
Your response must be concise. 0.37. In the year 2006, what is the difference between the Expenditure(as % of GDP) of Benin and Expenditure(as % of GDP) of Lao PDR?
Provide a short and direct response. 0.87. In the year 2006, what is the difference between the Expenditure(as % of GDP) in Djibouti and Expenditure(as % of GDP) in Japan?
Provide a succinct answer. 4.82. In the year 2006, what is the difference between the Expenditure(as % of GDP) in Djibouti and Expenditure(as % of GDP) in Lao PDR?
Your response must be concise. 5.32. In the year 2006, what is the difference between the Expenditure(as % of GDP) of Japan and Expenditure(as % of GDP) of Lao PDR?
Give a very brief answer. 0.5. In the year 2007, what is the difference between the Expenditure(as % of GDP) in Benin and Expenditure(as % of GDP) in Djibouti?
Ensure brevity in your answer.  -4.91. In the year 2007, what is the difference between the Expenditure(as % of GDP) of Benin and Expenditure(as % of GDP) of Japan?
Provide a short and direct response. 0.03. In the year 2007, what is the difference between the Expenditure(as % of GDP) in Benin and Expenditure(as % of GDP) in Lao PDR?
Offer a terse response. 0.42. In the year 2007, what is the difference between the Expenditure(as % of GDP) in Djibouti and Expenditure(as % of GDP) in Japan?
Your answer should be compact. 4.94. In the year 2007, what is the difference between the Expenditure(as % of GDP) of Djibouti and Expenditure(as % of GDP) of Lao PDR?
Ensure brevity in your answer.  5.33. In the year 2007, what is the difference between the Expenditure(as % of GDP) of Japan and Expenditure(as % of GDP) of Lao PDR?
Make the answer very short. 0.39. What is the ratio of the Expenditure(as % of GDP) in Benin in 2000 to that in 2001?
Your answer should be compact. 0.91. What is the ratio of the Expenditure(as % of GDP) in Djibouti in 2000 to that in 2001?
Your response must be concise. 1.24. What is the ratio of the Expenditure(as % of GDP) in Japan in 2000 to that in 2001?
Offer a very short reply. 1.01. What is the ratio of the Expenditure(as % of GDP) of Lao PDR in 2000 to that in 2001?
Provide a succinct answer. 0.76. What is the ratio of the Expenditure(as % of GDP) in Benin in 2000 to that in 2002?
Offer a terse response. 0.98. What is the ratio of the Expenditure(as % of GDP) in Djibouti in 2000 to that in 2002?
Offer a terse response. 1.14. What is the ratio of the Expenditure(as % of GDP) of Japan in 2000 to that in 2002?
Your response must be concise. 1.01. What is the ratio of the Expenditure(as % of GDP) in Lao PDR in 2000 to that in 2002?
Your answer should be very brief. 0.53. What is the ratio of the Expenditure(as % of GDP) of Benin in 2000 to that in 2004?
Your answer should be compact. 0.8. What is the ratio of the Expenditure(as % of GDP) of Djibouti in 2000 to that in 2004?
Offer a terse response. 1.04. What is the ratio of the Expenditure(as % of GDP) of Japan in 2000 to that in 2004?
Offer a very short reply. 1.01. What is the ratio of the Expenditure(as % of GDP) in Lao PDR in 2000 to that in 2004?
Offer a terse response. 0.62. What is the ratio of the Expenditure(as % of GDP) in Benin in 2000 to that in 2005?
Provide a succinct answer. 0.79. What is the ratio of the Expenditure(as % of GDP) in Djibouti in 2000 to that in 2005?
Your answer should be compact. 1.15. What is the ratio of the Expenditure(as % of GDP) of Japan in 2000 to that in 2005?
Your answer should be compact. 1.04. What is the ratio of the Expenditure(as % of GDP) in Lao PDR in 2000 to that in 2005?
Your response must be concise. 0.62. What is the ratio of the Expenditure(as % of GDP) of Benin in 2000 to that in 2006?
Your answer should be compact. 0.82. What is the ratio of the Expenditure(as % of GDP) in Djibouti in 2000 to that in 2006?
Keep it short and to the point. 1.17. What is the ratio of the Expenditure(as % of GDP) of Japan in 2000 to that in 2006?
Offer a very short reply. 1.05. What is the ratio of the Expenditure(as % of GDP) of Lao PDR in 2000 to that in 2006?
Make the answer very short. 0.51. What is the ratio of the Expenditure(as % of GDP) in Benin in 2000 to that in 2007?
Keep it short and to the point. 0.9. What is the ratio of the Expenditure(as % of GDP) in Djibouti in 2000 to that in 2007?
Offer a very short reply. 1.15. What is the ratio of the Expenditure(as % of GDP) of Japan in 2000 to that in 2007?
Offer a terse response. 1.04. What is the ratio of the Expenditure(as % of GDP) of Lao PDR in 2000 to that in 2007?
Make the answer very short. 0.49. What is the ratio of the Expenditure(as % of GDP) of Benin in 2001 to that in 2002?
Offer a terse response. 1.08. What is the ratio of the Expenditure(as % of GDP) in Djibouti in 2001 to that in 2002?
Offer a terse response. 0.92. What is the ratio of the Expenditure(as % of GDP) in Japan in 2001 to that in 2002?
Your answer should be very brief. 1. What is the ratio of the Expenditure(as % of GDP) in Lao PDR in 2001 to that in 2002?
Offer a very short reply. 0.7. What is the ratio of the Expenditure(as % of GDP) in Benin in 2001 to that in 2004?
Your answer should be compact. 0.89. What is the ratio of the Expenditure(as % of GDP) of Djibouti in 2001 to that in 2004?
Offer a terse response. 0.84. What is the ratio of the Expenditure(as % of GDP) of Japan in 2001 to that in 2004?
Provide a short and direct response. 0.99. What is the ratio of the Expenditure(as % of GDP) of Lao PDR in 2001 to that in 2004?
Give a very brief answer. 0.82. What is the ratio of the Expenditure(as % of GDP) of Benin in 2001 to that in 2005?
Provide a short and direct response. 0.87. What is the ratio of the Expenditure(as % of GDP) of Djibouti in 2001 to that in 2005?
Your response must be concise. 0.93. What is the ratio of the Expenditure(as % of GDP) of Japan in 2001 to that in 2005?
Ensure brevity in your answer.  1.03. What is the ratio of the Expenditure(as % of GDP) in Lao PDR in 2001 to that in 2005?
Your answer should be very brief. 0.82. What is the ratio of the Expenditure(as % of GDP) of Benin in 2001 to that in 2006?
Make the answer very short. 0.91. What is the ratio of the Expenditure(as % of GDP) of Djibouti in 2001 to that in 2006?
Give a very brief answer. 0.94. What is the ratio of the Expenditure(as % of GDP) in Japan in 2001 to that in 2006?
Make the answer very short. 1.03. What is the ratio of the Expenditure(as % of GDP) in Lao PDR in 2001 to that in 2006?
Provide a short and direct response. 0.67. What is the ratio of the Expenditure(as % of GDP) of Benin in 2001 to that in 2007?
Your response must be concise. 0.99. What is the ratio of the Expenditure(as % of GDP) of Djibouti in 2001 to that in 2007?
Your answer should be very brief. 0.93. What is the ratio of the Expenditure(as % of GDP) in Japan in 2001 to that in 2007?
Ensure brevity in your answer.  1.03. What is the ratio of the Expenditure(as % of GDP) of Lao PDR in 2001 to that in 2007?
Give a very brief answer. 0.65. What is the ratio of the Expenditure(as % of GDP) of Benin in 2002 to that in 2004?
Your answer should be very brief. 0.82. What is the ratio of the Expenditure(as % of GDP) in Djibouti in 2002 to that in 2004?
Make the answer very short. 0.91. What is the ratio of the Expenditure(as % of GDP) in Japan in 2002 to that in 2004?
Your answer should be compact. 1. What is the ratio of the Expenditure(as % of GDP) in Lao PDR in 2002 to that in 2004?
Your answer should be very brief. 1.17. What is the ratio of the Expenditure(as % of GDP) of Benin in 2002 to that in 2005?
Your answer should be very brief. 0.8. What is the ratio of the Expenditure(as % of GDP) in Djibouti in 2002 to that in 2005?
Give a very brief answer. 1.01. What is the ratio of the Expenditure(as % of GDP) in Japan in 2002 to that in 2005?
Your answer should be very brief. 1.03. What is the ratio of the Expenditure(as % of GDP) of Lao PDR in 2002 to that in 2005?
Provide a succinct answer. 1.17. What is the ratio of the Expenditure(as % of GDP) in Benin in 2002 to that in 2006?
Ensure brevity in your answer.  0.84. What is the ratio of the Expenditure(as % of GDP) of Djibouti in 2002 to that in 2006?
Your response must be concise. 1.02. What is the ratio of the Expenditure(as % of GDP) in Japan in 2002 to that in 2006?
Offer a very short reply. 1.04. What is the ratio of the Expenditure(as % of GDP) in Lao PDR in 2002 to that in 2006?
Make the answer very short. 0.95. What is the ratio of the Expenditure(as % of GDP) of Benin in 2002 to that in 2007?
Offer a very short reply. 0.92. What is the ratio of the Expenditure(as % of GDP) of Japan in 2002 to that in 2007?
Give a very brief answer. 1.03. What is the ratio of the Expenditure(as % of GDP) in Lao PDR in 2002 to that in 2007?
Give a very brief answer. 0.92. What is the ratio of the Expenditure(as % of GDP) in Benin in 2004 to that in 2005?
Your answer should be compact. 0.98. What is the ratio of the Expenditure(as % of GDP) of Djibouti in 2004 to that in 2005?
Your answer should be very brief. 1.11. What is the ratio of the Expenditure(as % of GDP) in Japan in 2004 to that in 2005?
Give a very brief answer. 1.03. What is the ratio of the Expenditure(as % of GDP) in Benin in 2004 to that in 2006?
Offer a very short reply. 1.02. What is the ratio of the Expenditure(as % of GDP) of Djibouti in 2004 to that in 2006?
Your answer should be very brief. 1.12. What is the ratio of the Expenditure(as % of GDP) of Japan in 2004 to that in 2006?
Make the answer very short. 1.04. What is the ratio of the Expenditure(as % of GDP) in Lao PDR in 2004 to that in 2006?
Offer a very short reply. 0.82. What is the ratio of the Expenditure(as % of GDP) in Benin in 2004 to that in 2007?
Your answer should be very brief. 1.12. What is the ratio of the Expenditure(as % of GDP) in Djibouti in 2004 to that in 2007?
Keep it short and to the point. 1.1. What is the ratio of the Expenditure(as % of GDP) in Japan in 2004 to that in 2007?
Make the answer very short. 1.04. What is the ratio of the Expenditure(as % of GDP) of Lao PDR in 2004 to that in 2007?
Your response must be concise. 0.78. What is the ratio of the Expenditure(as % of GDP) of Benin in 2005 to that in 2006?
Ensure brevity in your answer.  1.05. What is the ratio of the Expenditure(as % of GDP) in Djibouti in 2005 to that in 2006?
Provide a succinct answer. 1.01. What is the ratio of the Expenditure(as % of GDP) in Japan in 2005 to that in 2006?
Keep it short and to the point. 1.01. What is the ratio of the Expenditure(as % of GDP) of Lao PDR in 2005 to that in 2006?
Keep it short and to the point. 0.82. What is the ratio of the Expenditure(as % of GDP) in Benin in 2005 to that in 2007?
Your answer should be compact. 1.14. What is the ratio of the Expenditure(as % of GDP) in Japan in 2005 to that in 2007?
Offer a terse response. 1.01. What is the ratio of the Expenditure(as % of GDP) of Lao PDR in 2005 to that in 2007?
Your answer should be compact. 0.78. What is the ratio of the Expenditure(as % of GDP) in Benin in 2006 to that in 2007?
Offer a very short reply. 1.09. What is the ratio of the Expenditure(as % of GDP) of Lao PDR in 2006 to that in 2007?
Make the answer very short. 0.96. What is the difference between the highest and the second highest Expenditure(as % of GDP) in Benin?
Offer a very short reply. 0.09. What is the difference between the highest and the second highest Expenditure(as % of GDP) in Djibouti?
Ensure brevity in your answer.  0.4. What is the difference between the highest and the second highest Expenditure(as % of GDP) in Japan?
Keep it short and to the point. 0.02. What is the difference between the highest and the second highest Expenditure(as % of GDP) in Lao PDR?
Your response must be concise. 0.12. What is the difference between the highest and the lowest Expenditure(as % of GDP) in Benin?
Your response must be concise. 0.86. What is the difference between the highest and the lowest Expenditure(as % of GDP) of Djibouti?
Make the answer very short. 1.85. What is the difference between the highest and the lowest Expenditure(as % of GDP) in Japan?
Your answer should be very brief. 0.16. What is the difference between the highest and the lowest Expenditure(as % of GDP) in Lao PDR?
Your answer should be very brief. 1.57. 